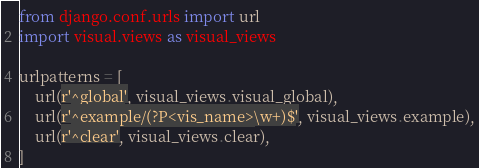Convert code to text. <code><loc_0><loc_0><loc_500><loc_500><_Python_>from django.conf.urls import url
import visual.views as visual_views

urlpatterns = [
    url(r'^global', visual_views.visual_global),
    url(r'^example/(?P<vis_name>\w+)$', visual_views.example),
    url(r'^clear', visual_views.clear),
]
</code> 